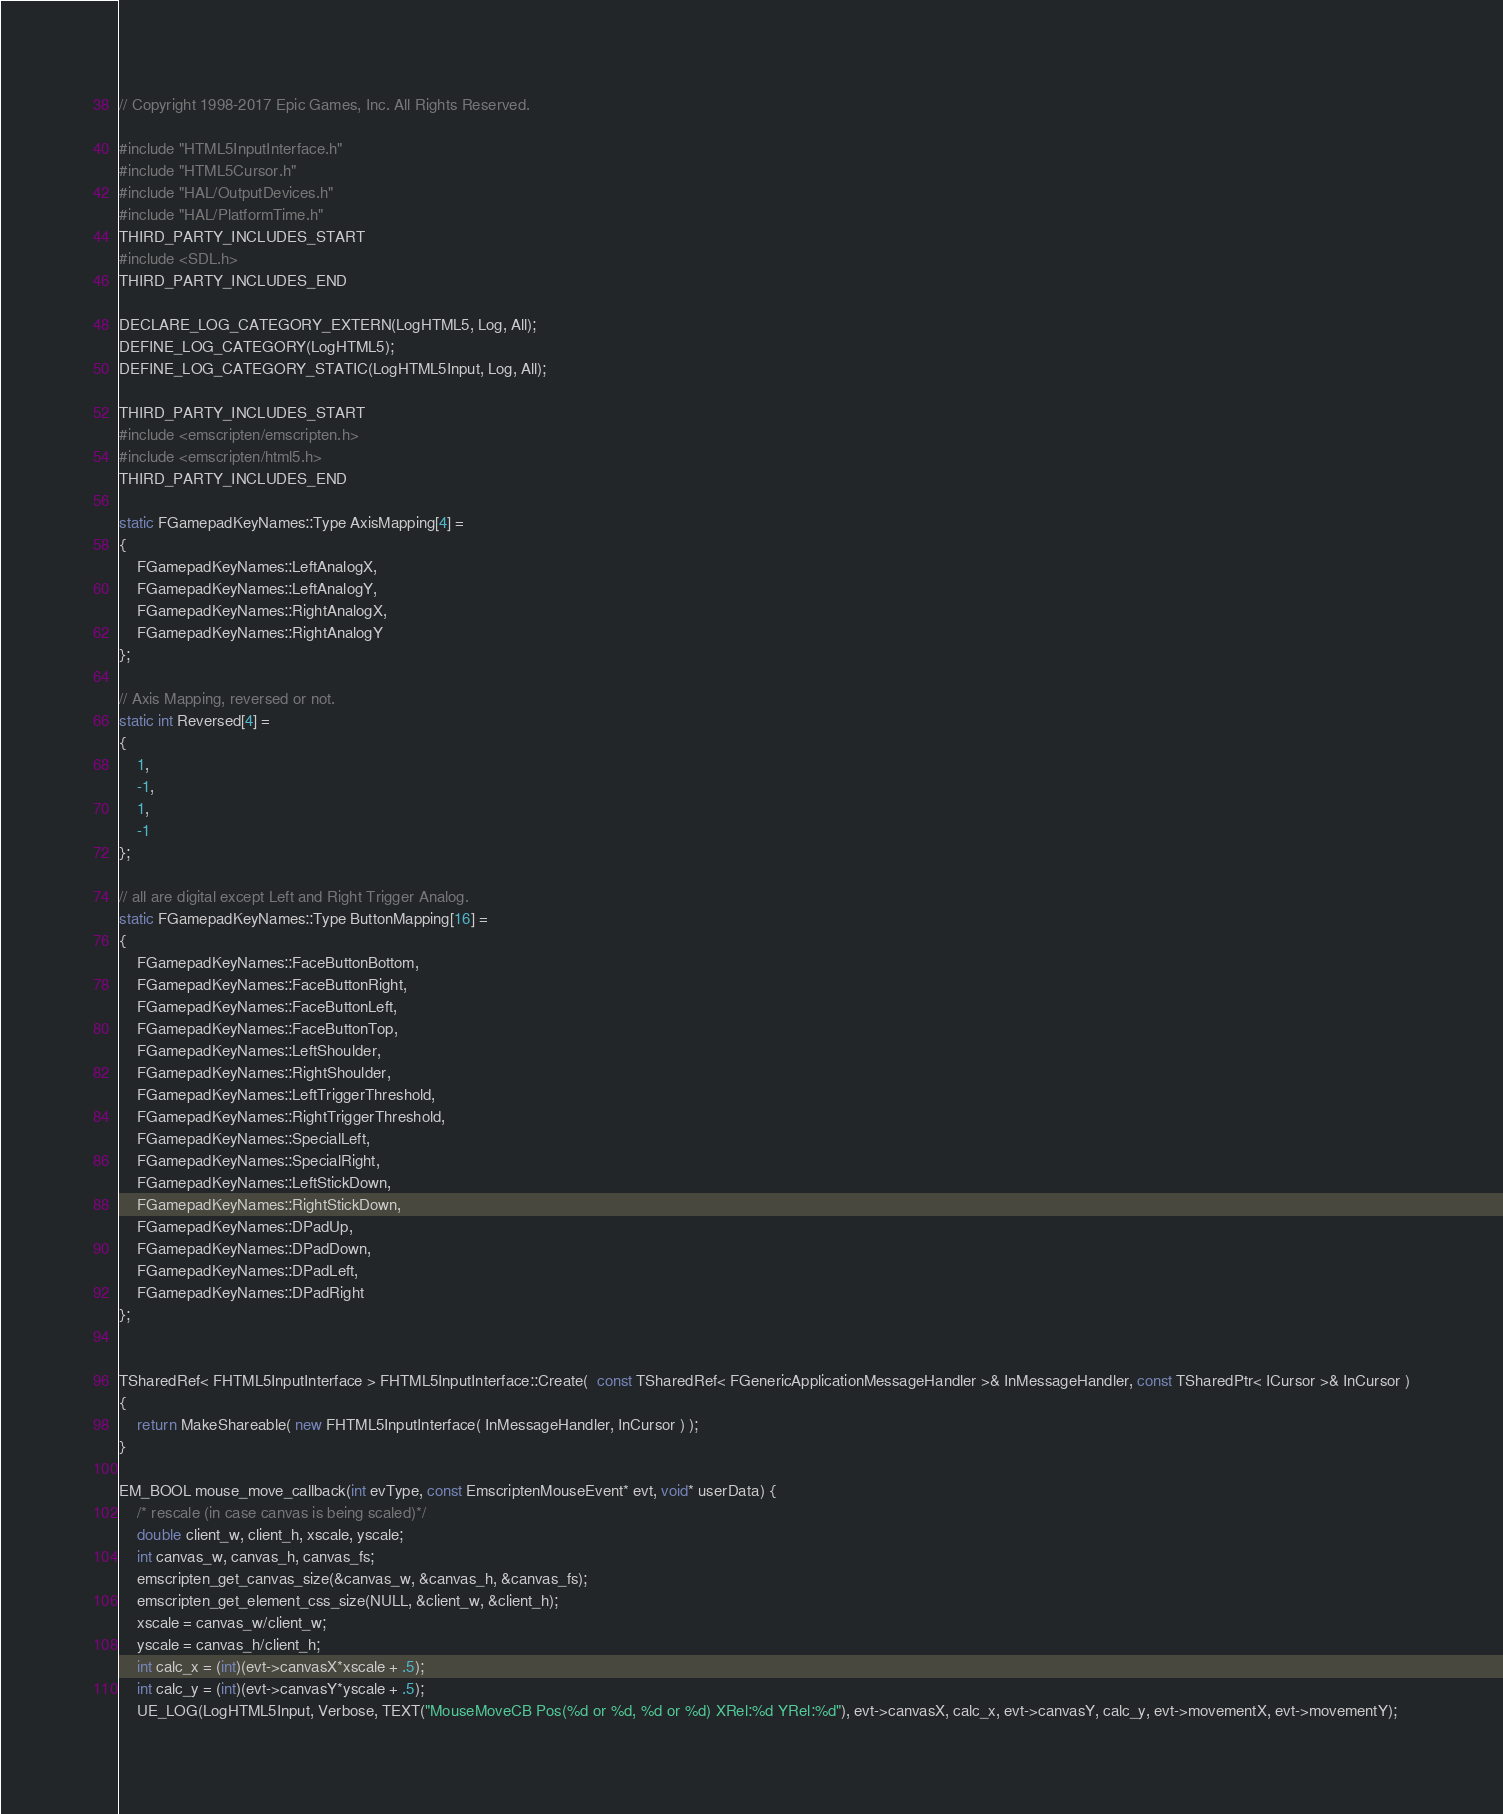<code> <loc_0><loc_0><loc_500><loc_500><_C++_>// Copyright 1998-2017 Epic Games, Inc. All Rights Reserved.

#include "HTML5InputInterface.h"
#include "HTML5Cursor.h"
#include "HAL/OutputDevices.h"
#include "HAL/PlatformTime.h"
THIRD_PARTY_INCLUDES_START
#include <SDL.h>
THIRD_PARTY_INCLUDES_END

DECLARE_LOG_CATEGORY_EXTERN(LogHTML5, Log, All);
DEFINE_LOG_CATEGORY(LogHTML5);
DEFINE_LOG_CATEGORY_STATIC(LogHTML5Input, Log, All);

THIRD_PARTY_INCLUDES_START
#include <emscripten/emscripten.h>
#include <emscripten/html5.h>
THIRD_PARTY_INCLUDES_END

static FGamepadKeyNames::Type AxisMapping[4] =
{
	FGamepadKeyNames::LeftAnalogX,
	FGamepadKeyNames::LeftAnalogY,
	FGamepadKeyNames::RightAnalogX,
	FGamepadKeyNames::RightAnalogY
};

// Axis Mapping, reversed or not.
static int Reversed[4] =
{
	1,
	-1,
	1,
	-1
};

// all are digital except Left and Right Trigger Analog.
static FGamepadKeyNames::Type ButtonMapping[16] =
{
	FGamepadKeyNames::FaceButtonBottom,
	FGamepadKeyNames::FaceButtonRight,
	FGamepadKeyNames::FaceButtonLeft,
	FGamepadKeyNames::FaceButtonTop,
	FGamepadKeyNames::LeftShoulder,
	FGamepadKeyNames::RightShoulder,
	FGamepadKeyNames::LeftTriggerThreshold,
	FGamepadKeyNames::RightTriggerThreshold,
	FGamepadKeyNames::SpecialLeft,
	FGamepadKeyNames::SpecialRight,
	FGamepadKeyNames::LeftStickDown,
	FGamepadKeyNames::RightStickDown,
	FGamepadKeyNames::DPadUp,
	FGamepadKeyNames::DPadDown,
	FGamepadKeyNames::DPadLeft,
	FGamepadKeyNames::DPadRight
};


TSharedRef< FHTML5InputInterface > FHTML5InputInterface::Create(  const TSharedRef< FGenericApplicationMessageHandler >& InMessageHandler, const TSharedPtr< ICursor >& InCursor )
{
	return MakeShareable( new FHTML5InputInterface( InMessageHandler, InCursor ) );
}

EM_BOOL mouse_move_callback(int evType, const EmscriptenMouseEvent* evt, void* userData) {
	/* rescale (in case canvas is being scaled)*/
	double client_w, client_h, xscale, yscale;
	int canvas_w, canvas_h, canvas_fs;
	emscripten_get_canvas_size(&canvas_w, &canvas_h, &canvas_fs);
	emscripten_get_element_css_size(NULL, &client_w, &client_h);
	xscale = canvas_w/client_w;
	yscale = canvas_h/client_h;
	int calc_x = (int)(evt->canvasX*xscale + .5);
	int calc_y = (int)(evt->canvasY*yscale + .5);
	UE_LOG(LogHTML5Input, Verbose, TEXT("MouseMoveCB Pos(%d or %d, %d or %d) XRel:%d YRel:%d"), evt->canvasX, calc_x, evt->canvasY, calc_y, evt->movementX, evt->movementY);</code> 